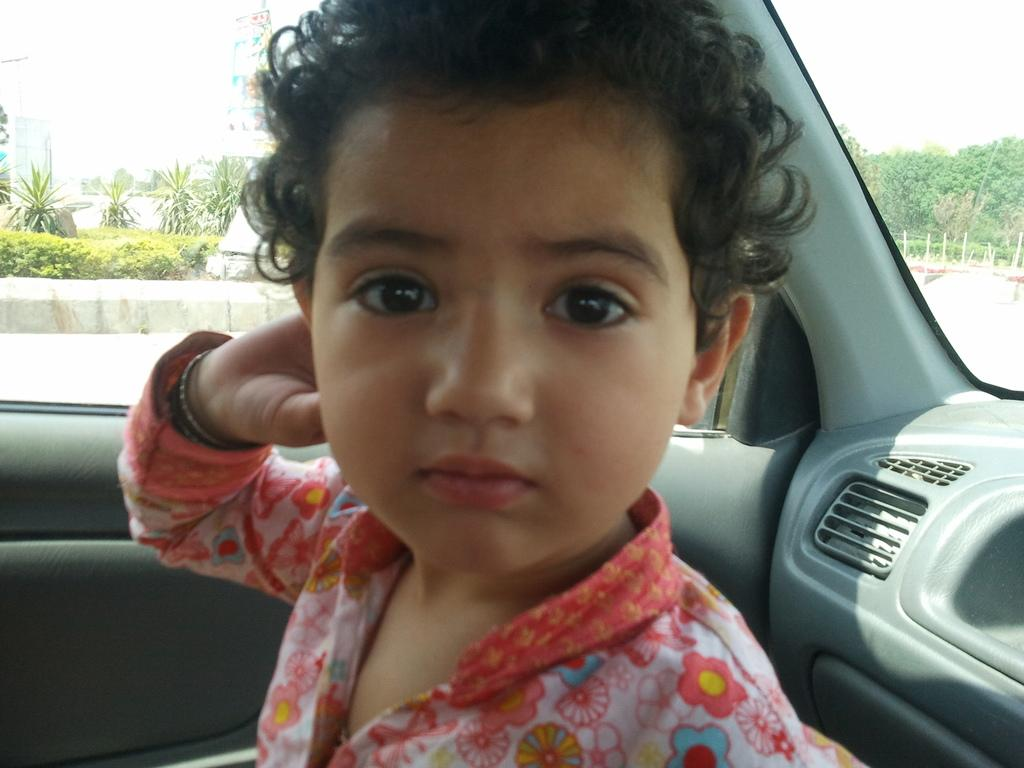What is the main subject of the image? The main subject of the image is a kid in a car. What can be seen in the background of the image? There are trees visible in the background of the image. What town is the kid saying good-bye to in the image? There is no indication in the image that the kid is saying good-bye to any town. How does the car move in the image? The car does not move in the image; it is stationary. 